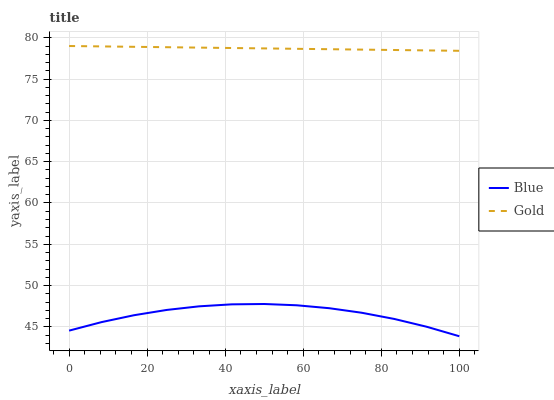Does Blue have the minimum area under the curve?
Answer yes or no. Yes. Does Gold have the maximum area under the curve?
Answer yes or no. Yes. Does Gold have the minimum area under the curve?
Answer yes or no. No. Is Gold the smoothest?
Answer yes or no. Yes. Is Blue the roughest?
Answer yes or no. Yes. Is Gold the roughest?
Answer yes or no. No. Does Blue have the lowest value?
Answer yes or no. Yes. Does Gold have the lowest value?
Answer yes or no. No. Does Gold have the highest value?
Answer yes or no. Yes. Is Blue less than Gold?
Answer yes or no. Yes. Is Gold greater than Blue?
Answer yes or no. Yes. Does Blue intersect Gold?
Answer yes or no. No. 